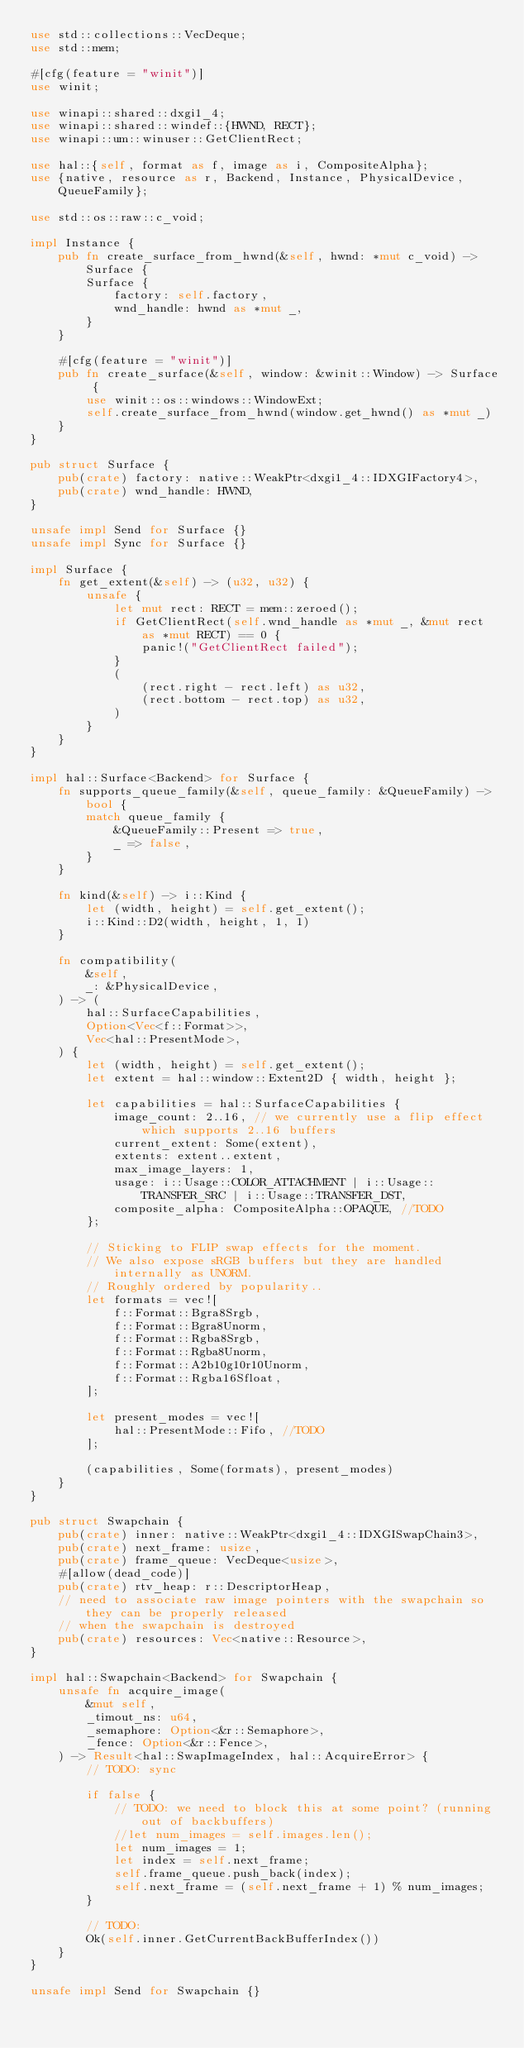<code> <loc_0><loc_0><loc_500><loc_500><_Rust_>use std::collections::VecDeque;
use std::mem;

#[cfg(feature = "winit")]
use winit;

use winapi::shared::dxgi1_4;
use winapi::shared::windef::{HWND, RECT};
use winapi::um::winuser::GetClientRect;

use hal::{self, format as f, image as i, CompositeAlpha};
use {native, resource as r, Backend, Instance, PhysicalDevice, QueueFamily};

use std::os::raw::c_void;

impl Instance {
    pub fn create_surface_from_hwnd(&self, hwnd: *mut c_void) -> Surface {
        Surface {
            factory: self.factory,
            wnd_handle: hwnd as *mut _,
        }
    }

    #[cfg(feature = "winit")]
    pub fn create_surface(&self, window: &winit::Window) -> Surface {
        use winit::os::windows::WindowExt;
        self.create_surface_from_hwnd(window.get_hwnd() as *mut _)
    }
}

pub struct Surface {
    pub(crate) factory: native::WeakPtr<dxgi1_4::IDXGIFactory4>,
    pub(crate) wnd_handle: HWND,
}

unsafe impl Send for Surface {}
unsafe impl Sync for Surface {}

impl Surface {
    fn get_extent(&self) -> (u32, u32) {
        unsafe {
            let mut rect: RECT = mem::zeroed();
            if GetClientRect(self.wnd_handle as *mut _, &mut rect as *mut RECT) == 0 {
                panic!("GetClientRect failed");
            }
            (
                (rect.right - rect.left) as u32,
                (rect.bottom - rect.top) as u32,
            )
        }
    }
}

impl hal::Surface<Backend> for Surface {
    fn supports_queue_family(&self, queue_family: &QueueFamily) -> bool {
        match queue_family {
            &QueueFamily::Present => true,
            _ => false,
        }
    }

    fn kind(&self) -> i::Kind {
        let (width, height) = self.get_extent();
        i::Kind::D2(width, height, 1, 1)
    }

    fn compatibility(
        &self,
        _: &PhysicalDevice,
    ) -> (
        hal::SurfaceCapabilities,
        Option<Vec<f::Format>>,
        Vec<hal::PresentMode>,
    ) {
        let (width, height) = self.get_extent();
        let extent = hal::window::Extent2D { width, height };

        let capabilities = hal::SurfaceCapabilities {
            image_count: 2..16, // we currently use a flip effect which supports 2..16 buffers
            current_extent: Some(extent),
            extents: extent..extent,
            max_image_layers: 1,
            usage: i::Usage::COLOR_ATTACHMENT | i::Usage::TRANSFER_SRC | i::Usage::TRANSFER_DST,
            composite_alpha: CompositeAlpha::OPAQUE, //TODO
        };

        // Sticking to FLIP swap effects for the moment.
        // We also expose sRGB buffers but they are handled internally as UNORM.
        // Roughly ordered by popularity..
        let formats = vec![
            f::Format::Bgra8Srgb,
            f::Format::Bgra8Unorm,
            f::Format::Rgba8Srgb,
            f::Format::Rgba8Unorm,
            f::Format::A2b10g10r10Unorm,
            f::Format::Rgba16Sfloat,
        ];

        let present_modes = vec![
            hal::PresentMode::Fifo, //TODO
        ];

        (capabilities, Some(formats), present_modes)
    }
}

pub struct Swapchain {
    pub(crate) inner: native::WeakPtr<dxgi1_4::IDXGISwapChain3>,
    pub(crate) next_frame: usize,
    pub(crate) frame_queue: VecDeque<usize>,
    #[allow(dead_code)]
    pub(crate) rtv_heap: r::DescriptorHeap,
    // need to associate raw image pointers with the swapchain so they can be properly released
    // when the swapchain is destroyed
    pub(crate) resources: Vec<native::Resource>,
}

impl hal::Swapchain<Backend> for Swapchain {
    unsafe fn acquire_image(
        &mut self,
        _timout_ns: u64,
        _semaphore: Option<&r::Semaphore>,
        _fence: Option<&r::Fence>,
    ) -> Result<hal::SwapImageIndex, hal::AcquireError> {
        // TODO: sync

        if false {
            // TODO: we need to block this at some point? (running out of backbuffers)
            //let num_images = self.images.len();
            let num_images = 1;
            let index = self.next_frame;
            self.frame_queue.push_back(index);
            self.next_frame = (self.next_frame + 1) % num_images;
        }

        // TODO:
        Ok(self.inner.GetCurrentBackBufferIndex())
    }
}

unsafe impl Send for Swapchain {}</code> 